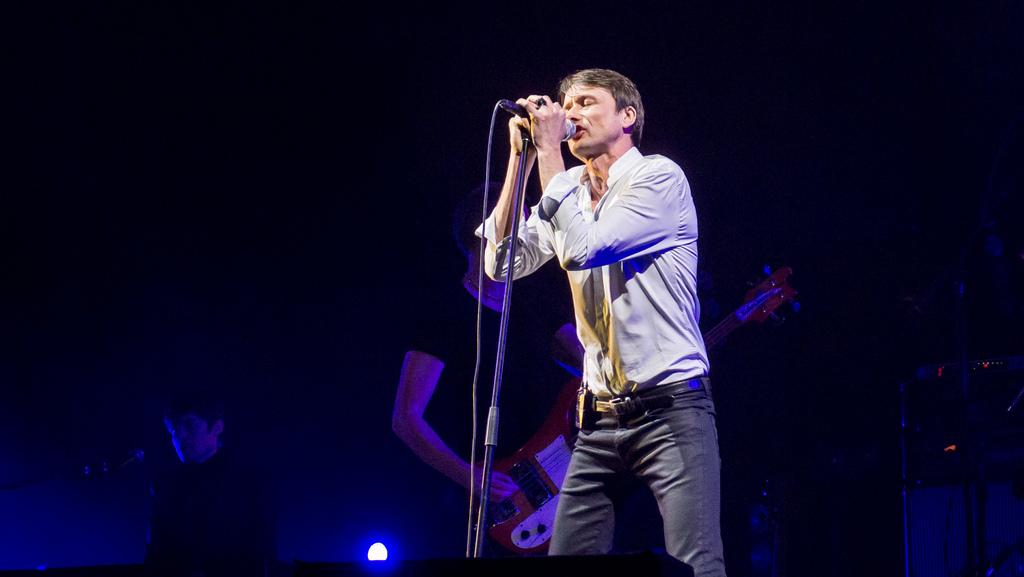What is the person on the stage doing? The person on the stage is singing into a microphone. Can you describe the person standing behind the singer? The man behind the singer is playing a musical instrument. What is the relationship between the two people on the stage? The person singing is likely being accompanied by the man playing the musical instrument. What type of statement is the person singing in the image? There is no indication in the image of the type of statement the person is singing. Can you tell me how many accounts the person singing has opened recently? There is no information about the person's accounts in the image. 